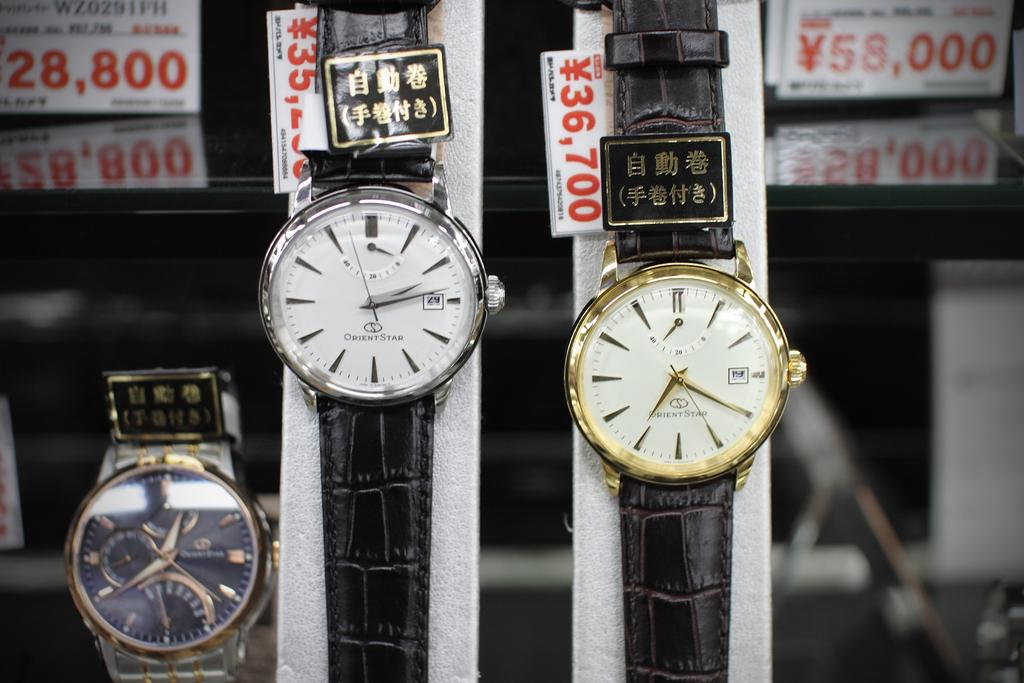<image>
Summarize the visual content of the image. A display with Orient Star brand watches, one with silver bezel, the other with gold and leather bands. 